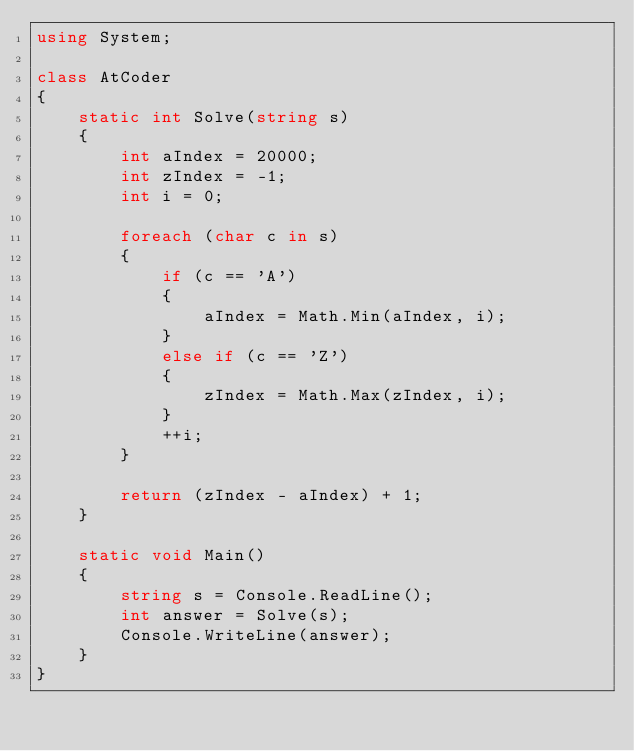Convert code to text. <code><loc_0><loc_0><loc_500><loc_500><_C#_>using System;

class AtCoder
{
    static int Solve(string s)
    {
        int aIndex = 20000;
        int zIndex = -1;
        int i = 0;

        foreach (char c in s)
        {
            if (c == 'A')
            {
                aIndex = Math.Min(aIndex, i);
            }
            else if (c == 'Z')
            {
                zIndex = Math.Max(zIndex, i);
            }
            ++i;
        }
        
        return (zIndex - aIndex) + 1;
    }

    static void Main()
    {
        string s = Console.ReadLine();
        int answer = Solve(s);
        Console.WriteLine(answer);
    }
}</code> 